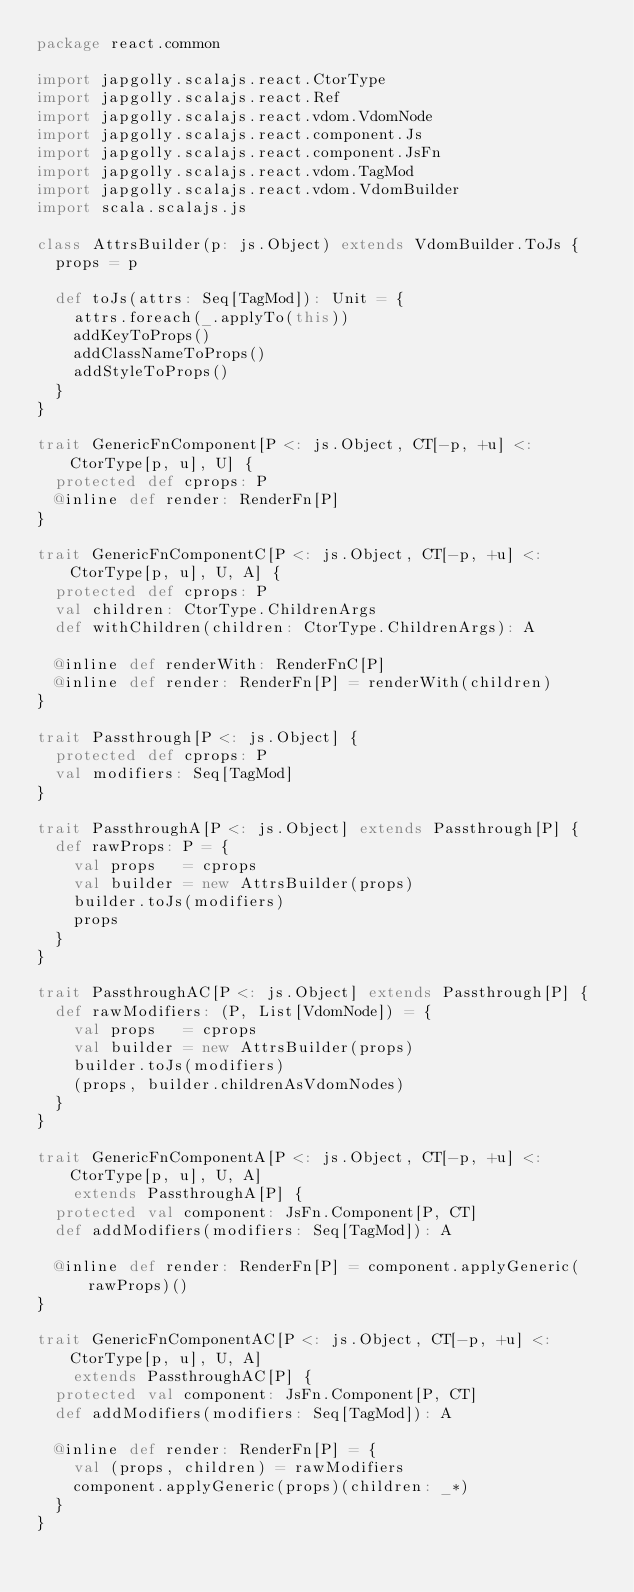Convert code to text. <code><loc_0><loc_0><loc_500><loc_500><_Scala_>package react.common

import japgolly.scalajs.react.CtorType
import japgolly.scalajs.react.Ref
import japgolly.scalajs.react.vdom.VdomNode
import japgolly.scalajs.react.component.Js
import japgolly.scalajs.react.component.JsFn
import japgolly.scalajs.react.vdom.TagMod
import japgolly.scalajs.react.vdom.VdomBuilder
import scala.scalajs.js

class AttrsBuilder(p: js.Object) extends VdomBuilder.ToJs {
  props = p

  def toJs(attrs: Seq[TagMod]): Unit = {
    attrs.foreach(_.applyTo(this))
    addKeyToProps()
    addClassNameToProps()
    addStyleToProps()
  }
}

trait GenericFnComponent[P <: js.Object, CT[-p, +u] <: CtorType[p, u], U] {
  protected def cprops: P
  @inline def render: RenderFn[P]
}

trait GenericFnComponentC[P <: js.Object, CT[-p, +u] <: CtorType[p, u], U, A] {
  protected def cprops: P
  val children: CtorType.ChildrenArgs
  def withChildren(children: CtorType.ChildrenArgs): A

  @inline def renderWith: RenderFnC[P]
  @inline def render: RenderFn[P] = renderWith(children)
}

trait Passthrough[P <: js.Object] {
  protected def cprops: P
  val modifiers: Seq[TagMod]
}

trait PassthroughA[P <: js.Object] extends Passthrough[P] {
  def rawProps: P = {
    val props   = cprops
    val builder = new AttrsBuilder(props)
    builder.toJs(modifiers)
    props
  }
}

trait PassthroughAC[P <: js.Object] extends Passthrough[P] {
  def rawModifiers: (P, List[VdomNode]) = {
    val props   = cprops
    val builder = new AttrsBuilder(props)
    builder.toJs(modifiers)
    (props, builder.childrenAsVdomNodes)
  }
}

trait GenericFnComponentA[P <: js.Object, CT[-p, +u] <: CtorType[p, u], U, A]
    extends PassthroughA[P] {
  protected val component: JsFn.Component[P, CT]
  def addModifiers(modifiers: Seq[TagMod]): A

  @inline def render: RenderFn[P] = component.applyGeneric(rawProps)()
}

trait GenericFnComponentAC[P <: js.Object, CT[-p, +u] <: CtorType[p, u], U, A]
    extends PassthroughAC[P] {
  protected val component: JsFn.Component[P, CT]
  def addModifiers(modifiers: Seq[TagMod]): A

  @inline def render: RenderFn[P] = {
    val (props, children) = rawModifiers
    component.applyGeneric(props)(children: _*)
  }
}
</code> 